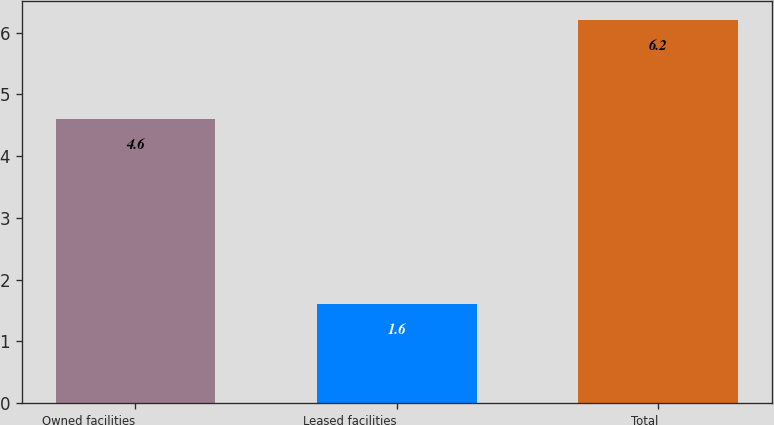Convert chart to OTSL. <chart><loc_0><loc_0><loc_500><loc_500><bar_chart><fcel>Owned facilities<fcel>Leased facilities<fcel>Total<nl><fcel>4.6<fcel>1.6<fcel>6.2<nl></chart> 